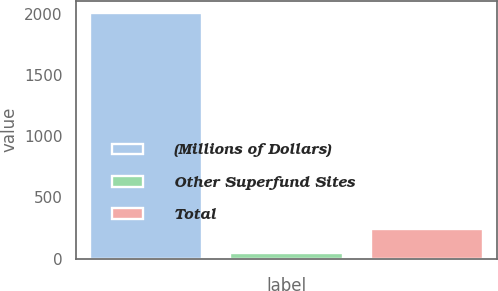Convert chart. <chart><loc_0><loc_0><loc_500><loc_500><bar_chart><fcel>(Millions of Dollars)<fcel>Other Superfund Sites<fcel>Total<nl><fcel>2004<fcel>50<fcel>245.4<nl></chart> 